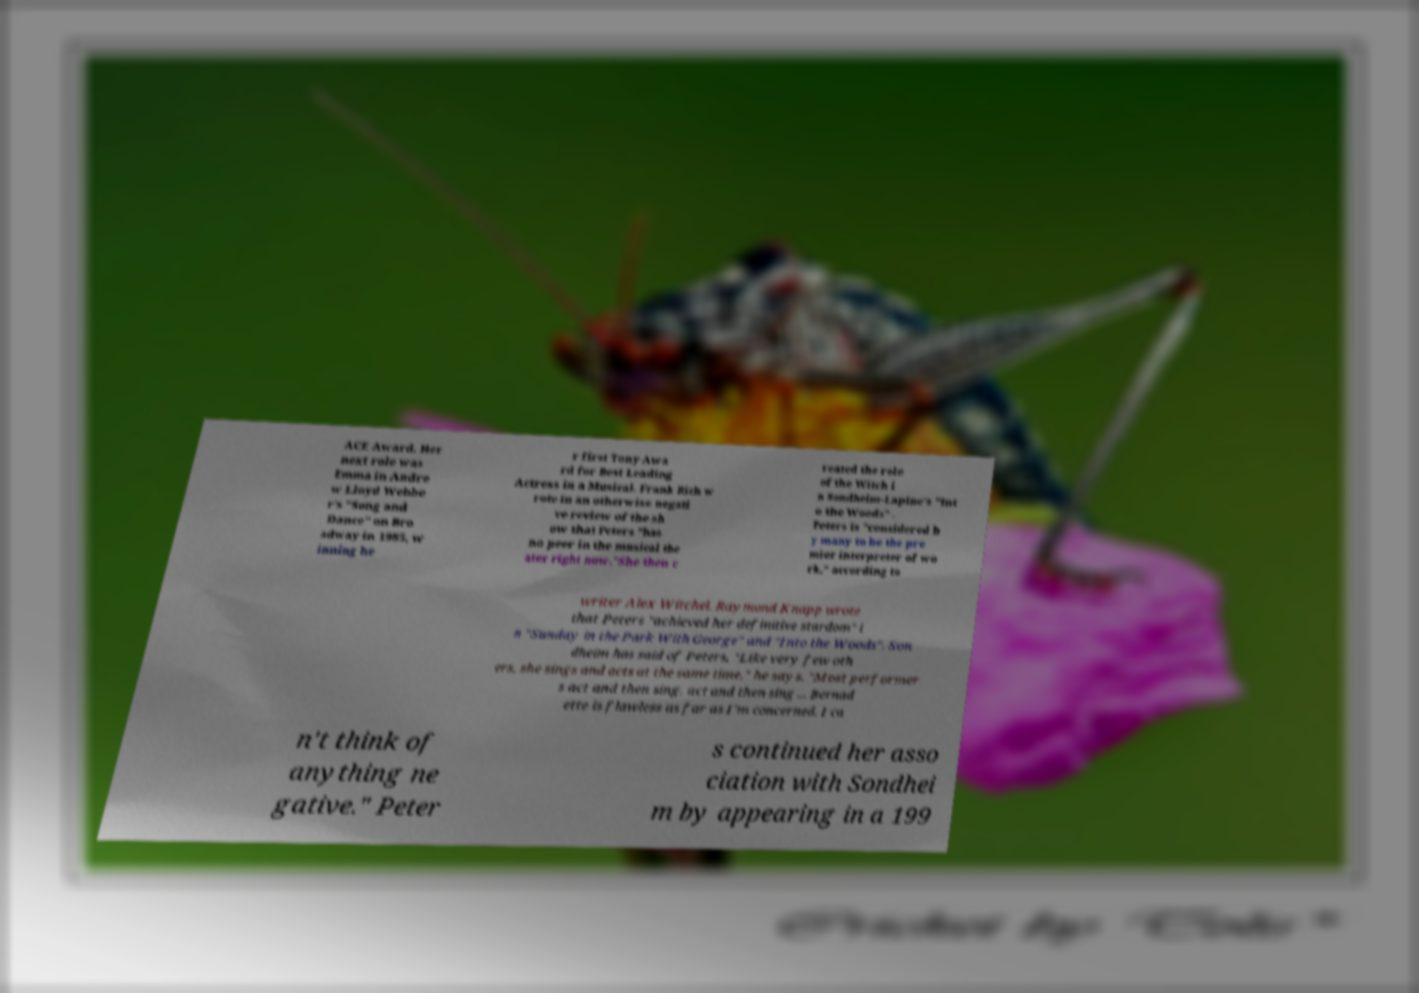Can you read and provide the text displayed in the image?This photo seems to have some interesting text. Can you extract and type it out for me? ACE Award. Her next role was Emma in Andre w Lloyd Webbe r's "Song and Dance" on Bro adway in 1985, w inning he r first Tony Awa rd for Best Leading Actress in a Musical. Frank Rich w rote in an otherwise negati ve review of the sh ow that Peters "has no peer in the musical the ater right now."She then c reated the role of the Witch i n Sondheim-Lapine's "Int o the Woods" . Peters is "considered b y many to be the pre mier interpreter of wo rk," according to writer Alex Witchel. Raymond Knapp wrote that Peters "achieved her definitive stardom" i n "Sunday in the Park With George" and "Into the Woods". Son dheim has said of Peters, "Like very few oth ers, she sings and acts at the same time," he says. "Most performer s act and then sing, act and then sing ... Bernad ette is flawless as far as I'm concerned. I ca n't think of anything ne gative." Peter s continued her asso ciation with Sondhei m by appearing in a 199 